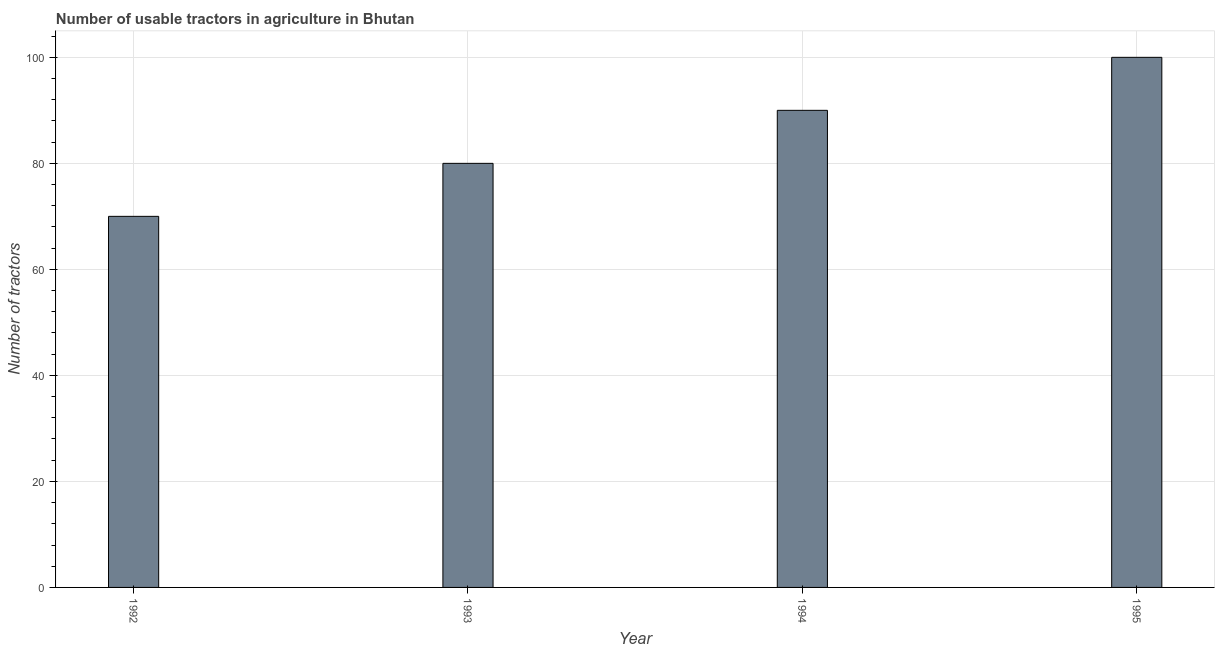What is the title of the graph?
Give a very brief answer. Number of usable tractors in agriculture in Bhutan. What is the label or title of the Y-axis?
Your answer should be very brief. Number of tractors. Across all years, what is the minimum number of tractors?
Offer a terse response. 70. In which year was the number of tractors maximum?
Your answer should be compact. 1995. In which year was the number of tractors minimum?
Give a very brief answer. 1992. What is the sum of the number of tractors?
Offer a terse response. 340. What is the ratio of the number of tractors in 1993 to that in 1994?
Make the answer very short. 0.89. Is the number of tractors in 1992 less than that in 1995?
Make the answer very short. Yes. What is the difference between the highest and the lowest number of tractors?
Provide a succinct answer. 30. In how many years, is the number of tractors greater than the average number of tractors taken over all years?
Ensure brevity in your answer.  2. How many bars are there?
Give a very brief answer. 4. What is the difference between two consecutive major ticks on the Y-axis?
Your answer should be very brief. 20. Are the values on the major ticks of Y-axis written in scientific E-notation?
Your response must be concise. No. What is the Number of tractors in 1992?
Keep it short and to the point. 70. What is the Number of tractors of 1995?
Your response must be concise. 100. What is the difference between the Number of tractors in 1992 and 1993?
Make the answer very short. -10. What is the difference between the Number of tractors in 1992 and 1994?
Keep it short and to the point. -20. What is the difference between the Number of tractors in 1993 and 1995?
Ensure brevity in your answer.  -20. What is the difference between the Number of tractors in 1994 and 1995?
Keep it short and to the point. -10. What is the ratio of the Number of tractors in 1992 to that in 1993?
Provide a short and direct response. 0.88. What is the ratio of the Number of tractors in 1992 to that in 1994?
Offer a terse response. 0.78. What is the ratio of the Number of tractors in 1993 to that in 1994?
Give a very brief answer. 0.89. What is the ratio of the Number of tractors in 1994 to that in 1995?
Offer a terse response. 0.9. 